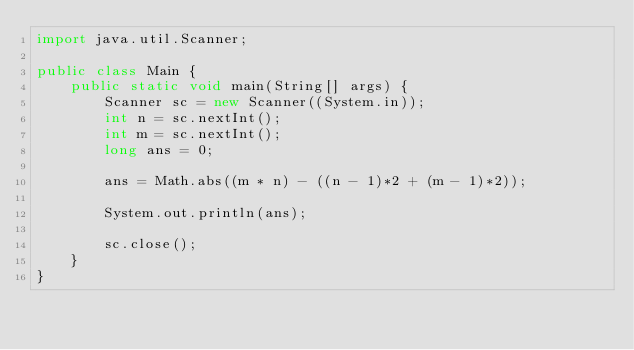<code> <loc_0><loc_0><loc_500><loc_500><_Java_>import java.util.Scanner;

public class Main {
	public static void main(String[] args) {
		Scanner sc = new Scanner((System.in));
		int n = sc.nextInt();
		int m = sc.nextInt();
		long ans = 0;

		ans = Math.abs((m * n) - ((n - 1)*2 + (m - 1)*2));
		
		System.out.println(ans);

		sc.close();
	}
}
</code> 